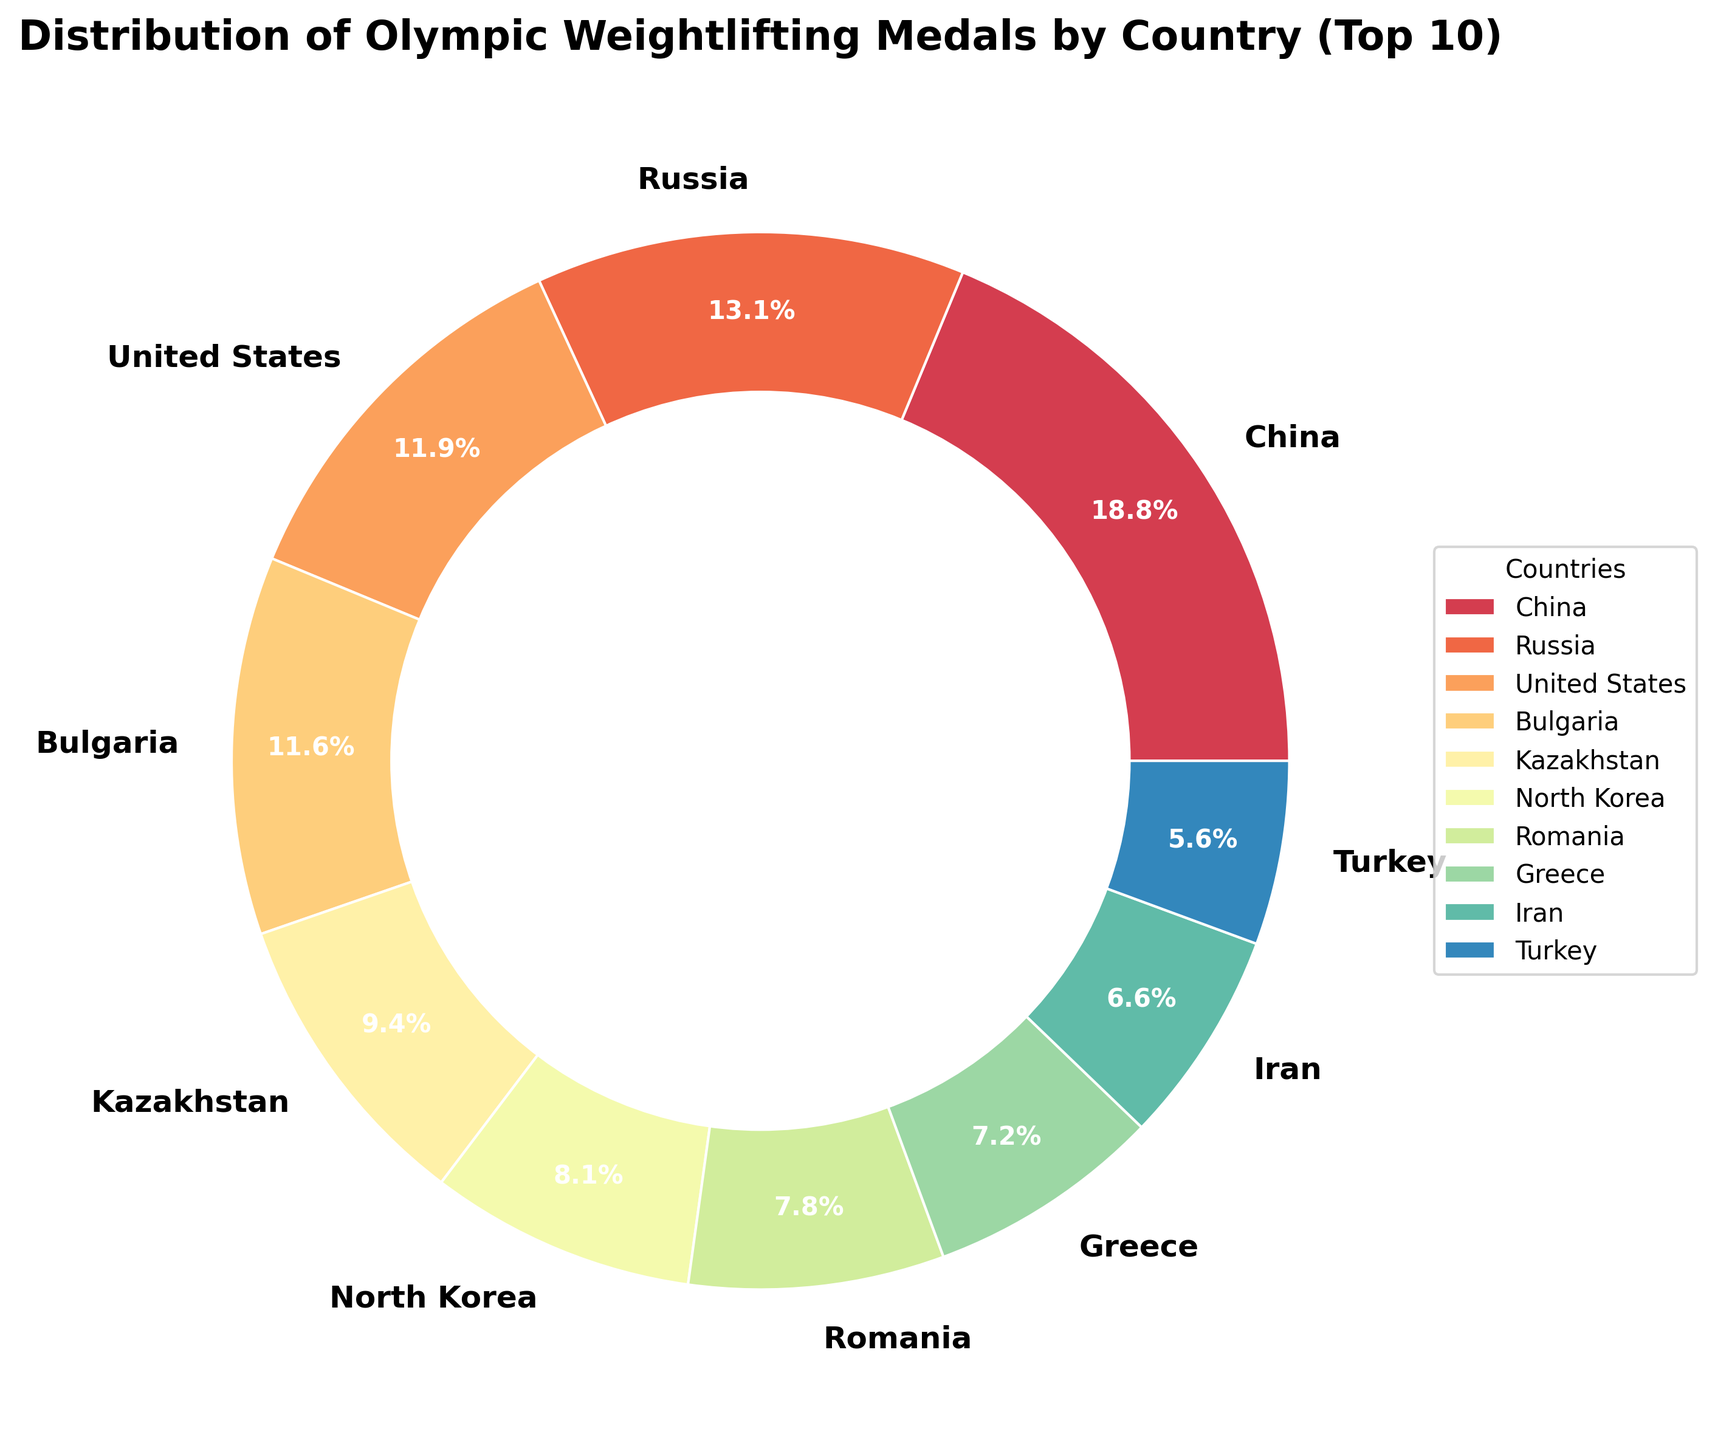How many countries are shown in the pie chart? The pie chart shows the distribution of Olympic weightlifting medals by country, and the data mentions that it displays the top 10 countries for better readability. So, there are 10 countries shown in the pie chart.
Answer: 10 Which country has won the highest number of medals in Olympic weightlifting? By observing the distribution and the size of the sections in the pie chart, the largest section corresponds to China, which has the highest medal count.
Answer: China How many medals have been won by the countries with the three smallest sections in the pie chart? The three smallest sections belong to Iran, Turkey, and Ukraine. Summing up their medal counts: Iran (21), Turkey (18), and Ukraine (15). The total is 21 + 18 + 15.
Answer: 54 Which two countries have a similar number of medals, and how many medals do they each have? By comparing section sizes, both the United States and Bulgaria have sections of similar size. They respectively have 38 and 37 medals.
Answer: United States, Bulgaria, 38, 37 What percentage of the total medals does Kazakhstan have in the pie chart? To find Kazakhstan's percentage, observe its section labeled with its percentage directly in the pie chart, Kazakhstan appears with the label of 9.1%.
Answer: 9.1% If you combine the medals from Russia and the United States, do they exceed China's medal count? Adding the medals from Russia (42) and the United States (38), the total is 42 + 38 = 80. China's medal count is 60, so the combined count exceeds China's.
Answer: Yes Rank the top three countries by their medal count according to the pie chart. Looking at the size and percentage labels of each section: 1) China, 2) Russia, 3) United States
Answer: China, Russia, United States Which country has slightly more medals, Romania or Greece, and by how many? Comparing the sections of Romania (25 medals) and Greece (23 medals), Romania has 2 more medals than Greece.
Answer: Romania, 2 Which country holds the 10th position in the medal count based on the pie chart? The country in the 10th position is Ukraine, as it has the smallest section among the top 10 countries depicted.
Answer: Ukraine What visual elements emphasize the distribution of medals in this chart? The pie chart uses a donut shape with different colors for each section, labeled percentages, and a legend that clarifies which color corresponds to which country, helping to distinguish and emphasize the distribution of medals.
Answer: Donut shape, colors, labeled percentages, legend 